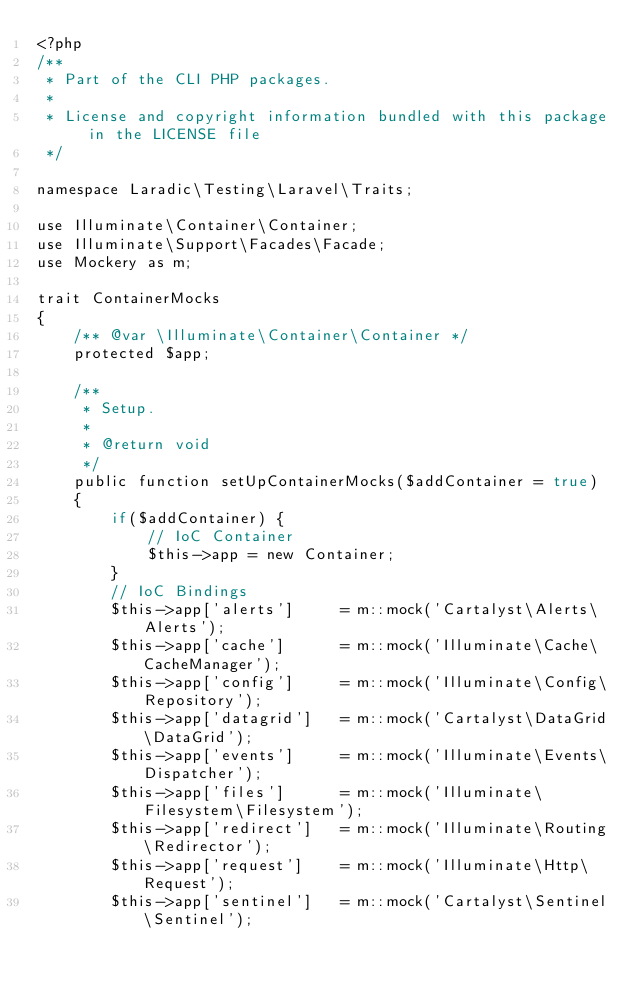<code> <loc_0><loc_0><loc_500><loc_500><_PHP_><?php
/**
 * Part of the CLI PHP packages.
 *
 * License and copyright information bundled with this package in the LICENSE file
 */

namespace Laradic\Testing\Laravel\Traits;

use Illuminate\Container\Container;
use Illuminate\Support\Facades\Facade;
use Mockery as m;

trait ContainerMocks
{
    /** @var \Illuminate\Container\Container */
    protected $app;

    /**
     * Setup.
     *
     * @return void
     */
    public function setUpContainerMocks($addContainer = true)
    {
        if($addContainer) {
            // IoC Container
            $this->app = new Container;
        }
        // IoC Bindings
        $this->app['alerts']     = m::mock('Cartalyst\Alerts\Alerts');
        $this->app['cache']      = m::mock('Illuminate\Cache\CacheManager');
        $this->app['config']     = m::mock('Illuminate\Config\Repository');
        $this->app['datagrid']   = m::mock('Cartalyst\DataGrid\DataGrid');
        $this->app['events']     = m::mock('Illuminate\Events\Dispatcher');
        $this->app['files']      = m::mock('Illuminate\Filesystem\Filesystem');
        $this->app['redirect']   = m::mock('Illuminate\Routing\Redirector');
        $this->app['request']    = m::mock('Illuminate\Http\Request');
        $this->app['sentinel']   = m::mock('Cartalyst\Sentinel\Sentinel');</code> 